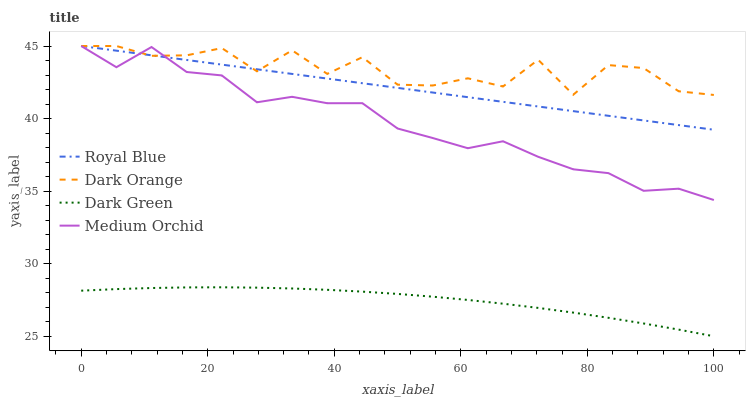Does Dark Green have the minimum area under the curve?
Answer yes or no. Yes. Does Dark Orange have the maximum area under the curve?
Answer yes or no. Yes. Does Medium Orchid have the minimum area under the curve?
Answer yes or no. No. Does Medium Orchid have the maximum area under the curve?
Answer yes or no. No. Is Royal Blue the smoothest?
Answer yes or no. Yes. Is Dark Orange the roughest?
Answer yes or no. Yes. Is Medium Orchid the smoothest?
Answer yes or no. No. Is Medium Orchid the roughest?
Answer yes or no. No. Does Dark Green have the lowest value?
Answer yes or no. Yes. Does Medium Orchid have the lowest value?
Answer yes or no. No. Does Dark Orange have the highest value?
Answer yes or no. Yes. Does Dark Green have the highest value?
Answer yes or no. No. Is Dark Green less than Medium Orchid?
Answer yes or no. Yes. Is Medium Orchid greater than Dark Green?
Answer yes or no. Yes. Does Royal Blue intersect Medium Orchid?
Answer yes or no. Yes. Is Royal Blue less than Medium Orchid?
Answer yes or no. No. Is Royal Blue greater than Medium Orchid?
Answer yes or no. No. Does Dark Green intersect Medium Orchid?
Answer yes or no. No. 